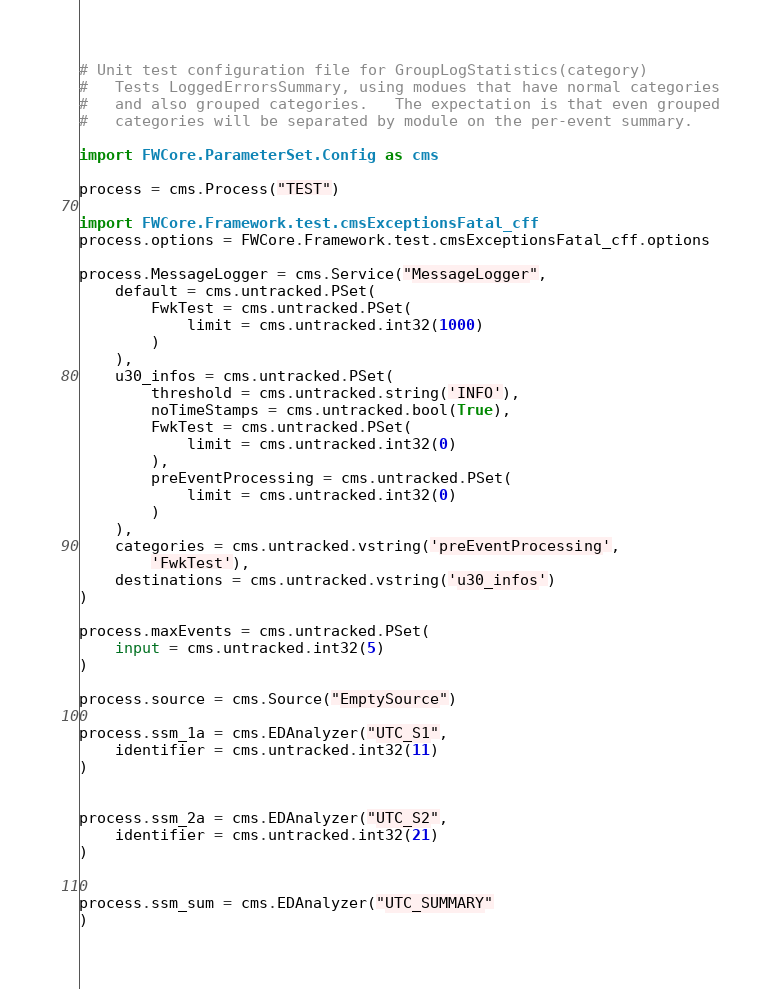Convert code to text. <code><loc_0><loc_0><loc_500><loc_500><_Python_># Unit test configuration file for GroupLogStatistics(category)
#   Tests LoggedErrorsSummary, using modues that have normal categories
#   and also grouped categories.   The expectation is that even grouped
#   categories will be separated by module on the per-event summary.

import FWCore.ParameterSet.Config as cms

process = cms.Process("TEST")

import FWCore.Framework.test.cmsExceptionsFatal_cff
process.options = FWCore.Framework.test.cmsExceptionsFatal_cff.options

process.MessageLogger = cms.Service("MessageLogger",
    default = cms.untracked.PSet(
        FwkTest = cms.untracked.PSet(
            limit = cms.untracked.int32(1000)
        )
    ),
    u30_infos = cms.untracked.PSet(
        threshold = cms.untracked.string('INFO'),
        noTimeStamps = cms.untracked.bool(True),
        FwkTest = cms.untracked.PSet(
            limit = cms.untracked.int32(0)
        ),
        preEventProcessing = cms.untracked.PSet(
            limit = cms.untracked.int32(0)
        )
    ),
    categories = cms.untracked.vstring('preEventProcessing', 
        'FwkTest'),
    destinations = cms.untracked.vstring('u30_infos')
)

process.maxEvents = cms.untracked.PSet(
    input = cms.untracked.int32(5)
)

process.source = cms.Source("EmptySource")

process.ssm_1a = cms.EDAnalyzer("UTC_S1",
    identifier = cms.untracked.int32(11)
)


process.ssm_2a = cms.EDAnalyzer("UTC_S2",
    identifier = cms.untracked.int32(21)
)


process.ssm_sum = cms.EDAnalyzer("UTC_SUMMARY"
)
</code> 